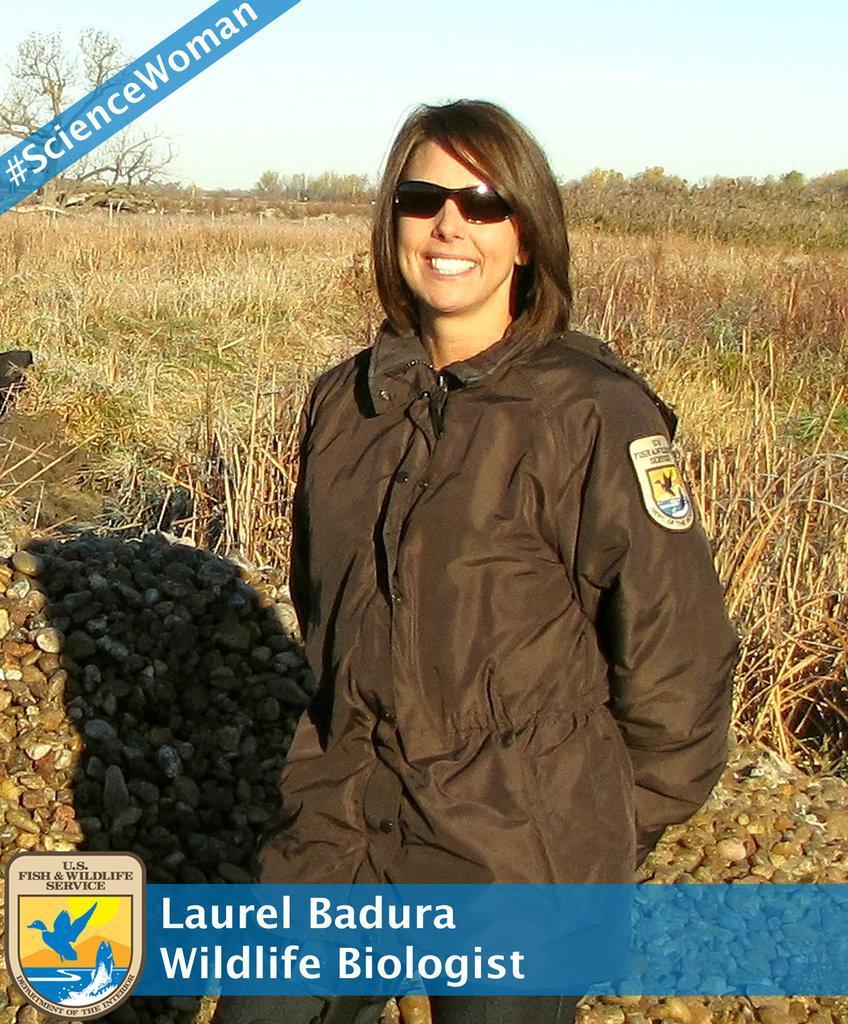Describe this image in one or two sentences. It is an edited image there is a woman standing in front of plants and behind the woman there are many stones, the name of the woman is mentioned below the picture. 